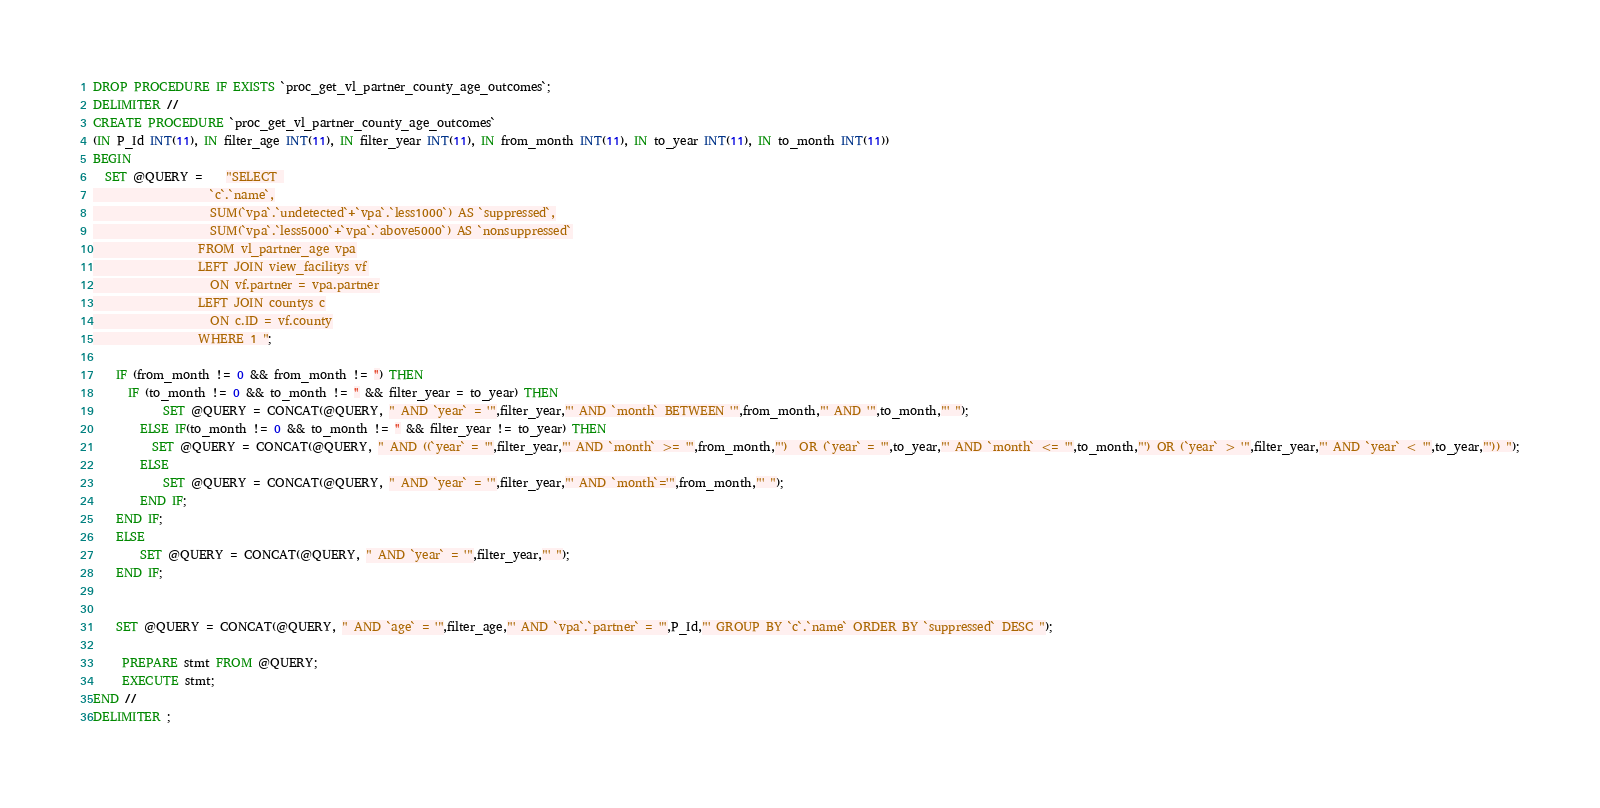Convert code to text. <code><loc_0><loc_0><loc_500><loc_500><_SQL_>DROP PROCEDURE IF EXISTS `proc_get_vl_partner_county_age_outcomes`;
DELIMITER //
CREATE PROCEDURE `proc_get_vl_partner_county_age_outcomes`
(IN P_Id INT(11), IN filter_age INT(11), IN filter_year INT(11), IN from_month INT(11), IN to_year INT(11), IN to_month INT(11))
BEGIN
  SET @QUERY =    "SELECT 
                    `c`.`name`,
                    SUM(`vpa`.`undetected`+`vpa`.`less1000`) AS `suppressed`,
                    SUM(`vpa`.`less5000`+`vpa`.`above5000`) AS `nonsuppressed`
                  FROM vl_partner_age vpa
                  LEFT JOIN view_facilitys vf
                    ON vf.partner = vpa.partner
                  LEFT JOIN countys c
                    ON c.ID = vf.county
                  WHERE 1 ";

    IF (from_month != 0 && from_month != '') THEN
      IF (to_month != 0 && to_month != '' && filter_year = to_year) THEN
            SET @QUERY = CONCAT(@QUERY, " AND `year` = '",filter_year,"' AND `month` BETWEEN '",from_month,"' AND '",to_month,"' ");
        ELSE IF(to_month != 0 && to_month != '' && filter_year != to_year) THEN
          SET @QUERY = CONCAT(@QUERY, " AND ((`year` = '",filter_year,"' AND `month` >= '",from_month,"')  OR (`year` = '",to_year,"' AND `month` <= '",to_month,"') OR (`year` > '",filter_year,"' AND `year` < '",to_year,"')) ");
        ELSE
            SET @QUERY = CONCAT(@QUERY, " AND `year` = '",filter_year,"' AND `month`='",from_month,"' ");
        END IF;
    END IF;
    ELSE
        SET @QUERY = CONCAT(@QUERY, " AND `year` = '",filter_year,"' ");
    END IF;


    SET @QUERY = CONCAT(@QUERY, " AND `age` = '",filter_age,"' AND `vpa`.`partner` = '",P_Id,"' GROUP BY `c`.`name` ORDER BY `suppressed` DESC ");

     PREPARE stmt FROM @QUERY;
     EXECUTE stmt;
END //
DELIMITER ;
</code> 